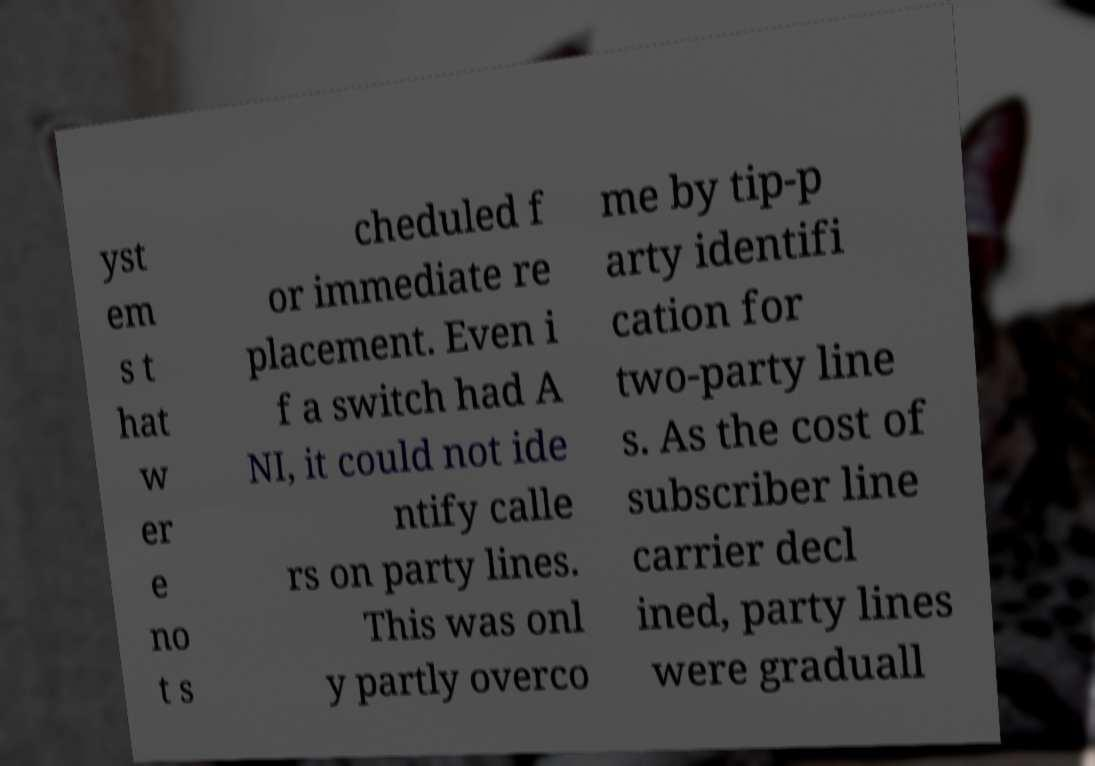Please identify and transcribe the text found in this image. yst em s t hat w er e no t s cheduled f or immediate re placement. Even i f a switch had A NI, it could not ide ntify calle rs on party lines. This was onl y partly overco me by tip-p arty identifi cation for two-party line s. As the cost of subscriber line carrier decl ined, party lines were graduall 